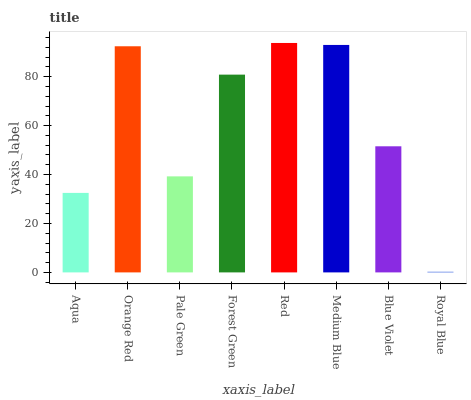Is Royal Blue the minimum?
Answer yes or no. Yes. Is Red the maximum?
Answer yes or no. Yes. Is Orange Red the minimum?
Answer yes or no. No. Is Orange Red the maximum?
Answer yes or no. No. Is Orange Red greater than Aqua?
Answer yes or no. Yes. Is Aqua less than Orange Red?
Answer yes or no. Yes. Is Aqua greater than Orange Red?
Answer yes or no. No. Is Orange Red less than Aqua?
Answer yes or no. No. Is Forest Green the high median?
Answer yes or no. Yes. Is Blue Violet the low median?
Answer yes or no. Yes. Is Medium Blue the high median?
Answer yes or no. No. Is Aqua the low median?
Answer yes or no. No. 